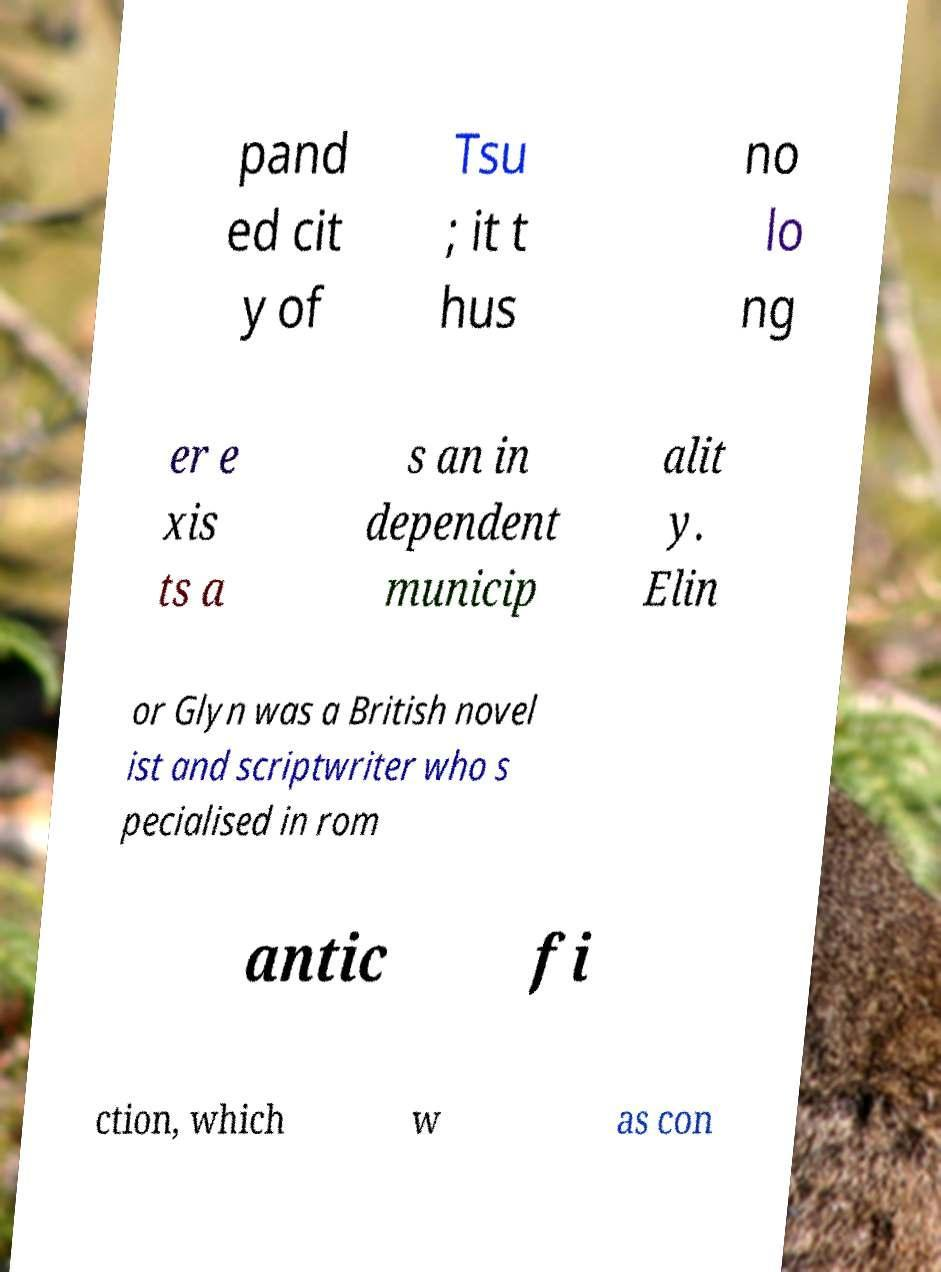Can you read and provide the text displayed in the image?This photo seems to have some interesting text. Can you extract and type it out for me? pand ed cit y of Tsu ; it t hus no lo ng er e xis ts a s an in dependent municip alit y. Elin or Glyn was a British novel ist and scriptwriter who s pecialised in rom antic fi ction, which w as con 